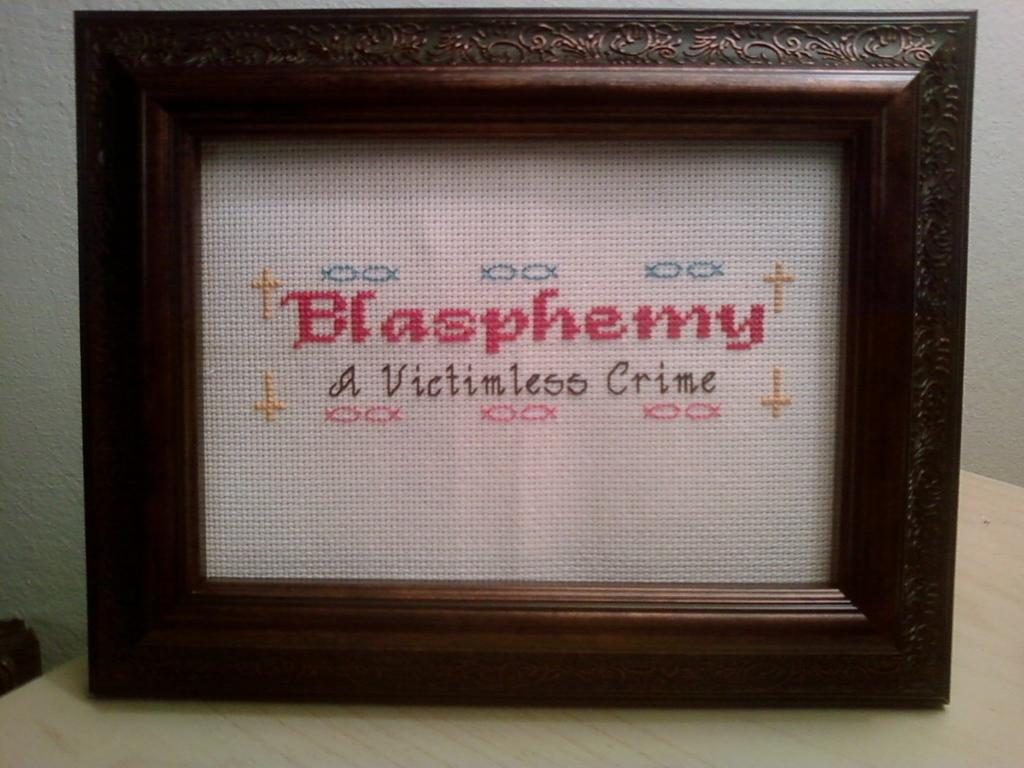<image>
Relay a brief, clear account of the picture shown. A framed cross stitch piece with the word Blasphemy in red letters. 